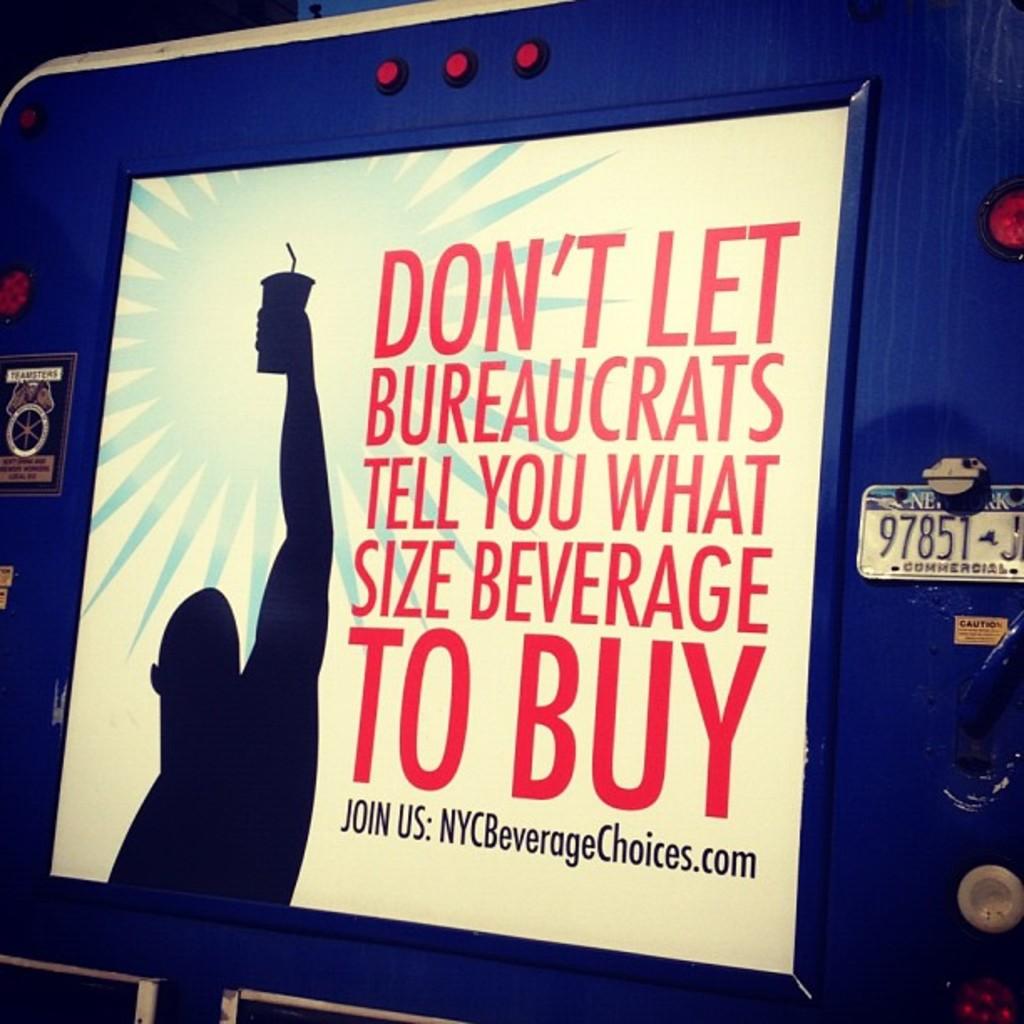What website is being advertised?
Your response must be concise. Nycbeveragechoices.com. What is the top word?
Keep it short and to the point. Don't. 